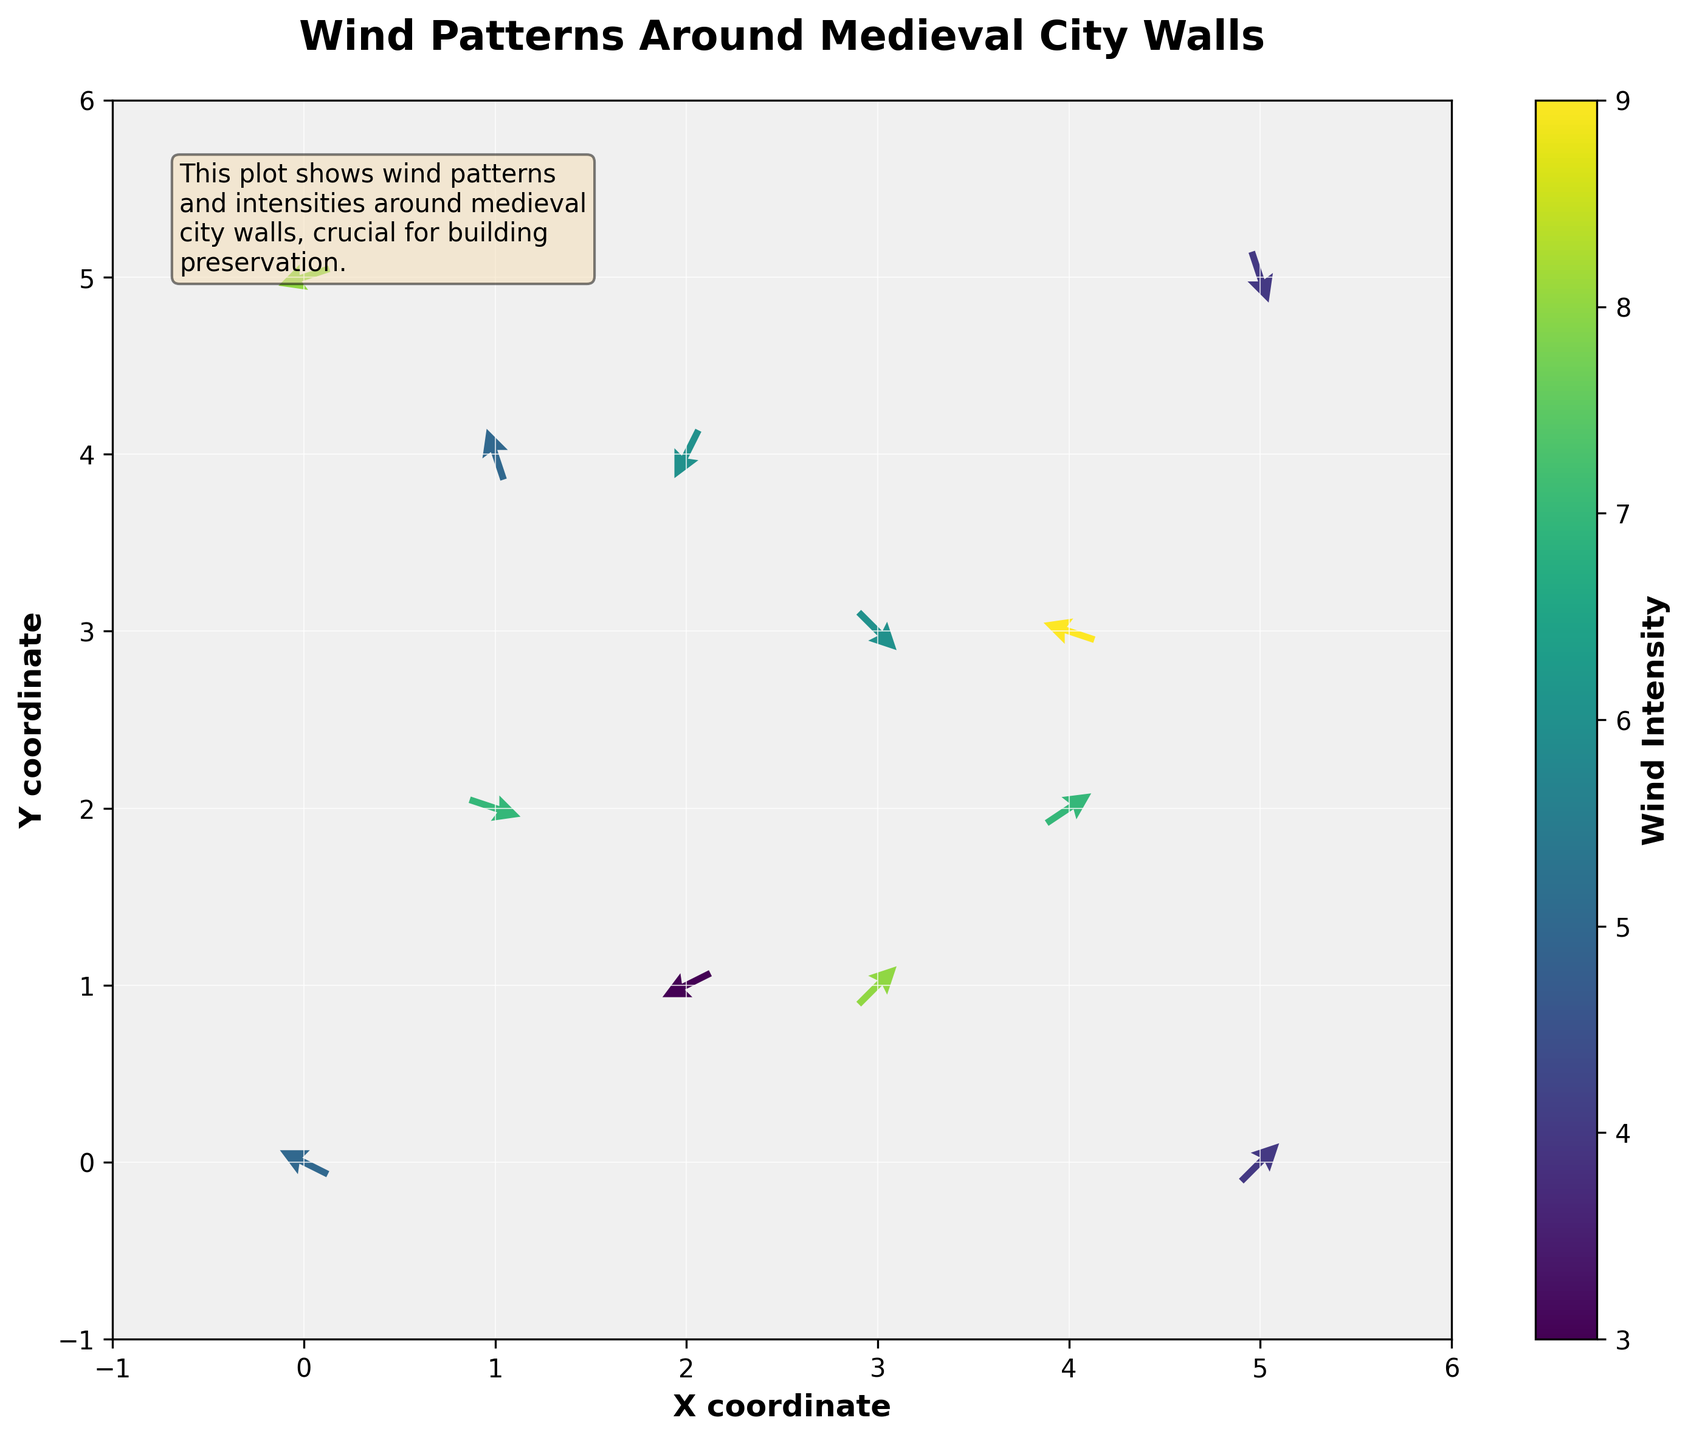Which quadrant shows the highest wind intensity? The intensity is represented by color, with darker shades indicating higher intensity. Observe where the darkest arrows are located.
Answer: Bottom-right What is the general direction of the wind at the point (2, 4)? At (2, 4), the arrow points downward and slightly to the left. This indicates a wind blowing from the top right towards the bottom left.
Answer: Downward-left Which coordinates experience a combination of high wind intensity and a downward direction? High wind intensity is shown in darker colors. Examine the arrows pointing downward that are also shaded darkly.
Answer: (4, 3) What range of wind intensities is represented in this plot? Refer to the color bar on the side of the plot, which indicates the range of wind intensities.
Answer: 3 to 9 Compare the wind intensity at (1, 2) with the intensity at (4, 2). Which is greater? Look at the color shades at these two points; the darker shade indicates higher intensity.
Answer: (4, 2) How many arrows point in a purely horizontal direction (either left or right)? Identify and count the arrows that are either perfectly horizontal in either direction.
Answer: 2 What is the average x-coordinate of the points with wind intensity above 7? Identify points with intensity > 7 and calculate the average of their x-coordinates: \( (3 + 4 + 3 + 0) / 4 \)
Answer: 2.5 Which point has the longest-magnitude arrow, indicating the strongest wind direction contribution? Longest arrows are seen by comparing the length; however, all arrows are normalized, look for standout features.
Answer: Cannot be determined from normalized arrows At which points do arrows converge, indicating potential turbulent areas? Look for areas where arrows from opposite directions are close to each other, indicating confluence.
Answer: (5, 0) and (0, 5) What does the color of the arrows suggest about the wind intensity over time? The color bar shows a scale from light to dark; darker arrows suggest higher average wind intensity at that point over time.
Answer: Higher intensity 